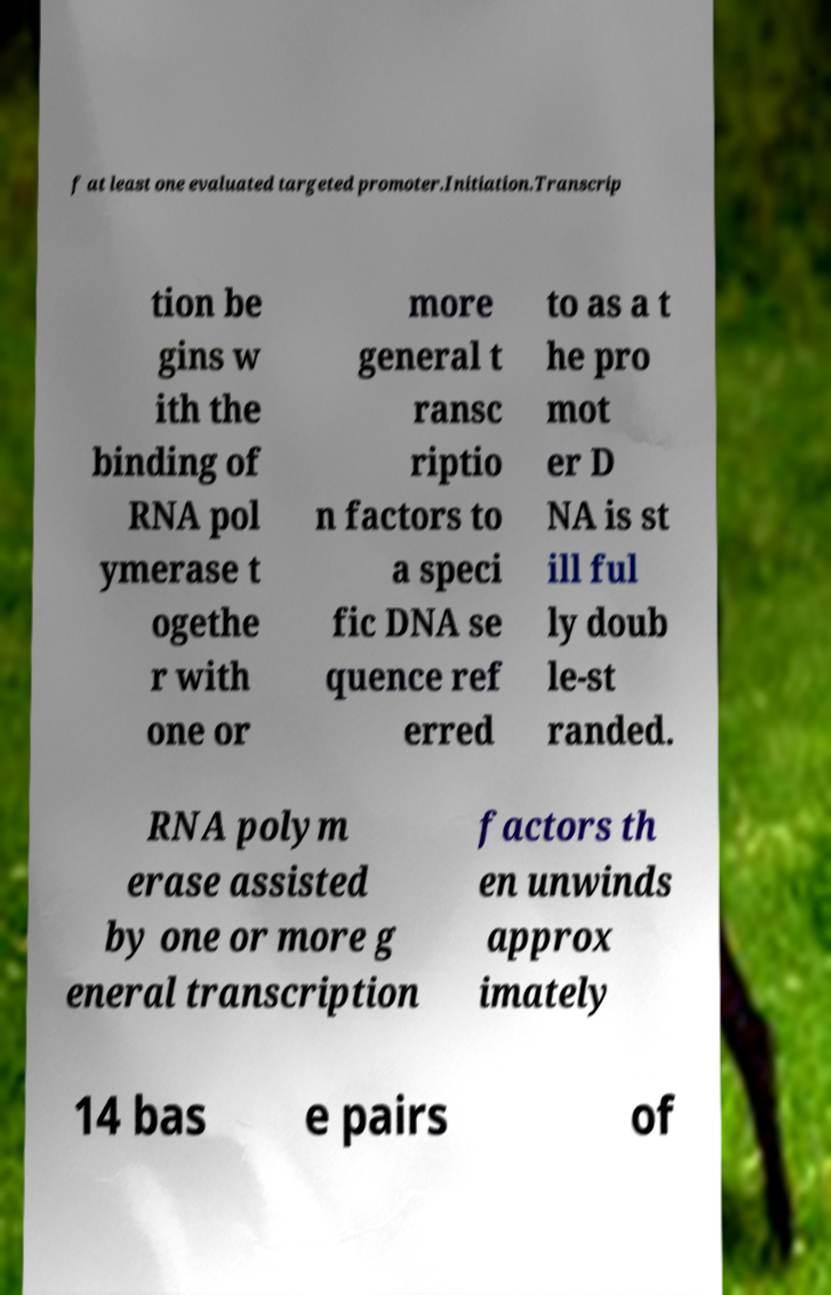Please identify and transcribe the text found in this image. f at least one evaluated targeted promoter.Initiation.Transcrip tion be gins w ith the binding of RNA pol ymerase t ogethe r with one or more general t ransc riptio n factors to a speci fic DNA se quence ref erred to as a t he pro mot er D NA is st ill ful ly doub le-st randed. RNA polym erase assisted by one or more g eneral transcription factors th en unwinds approx imately 14 bas e pairs of 